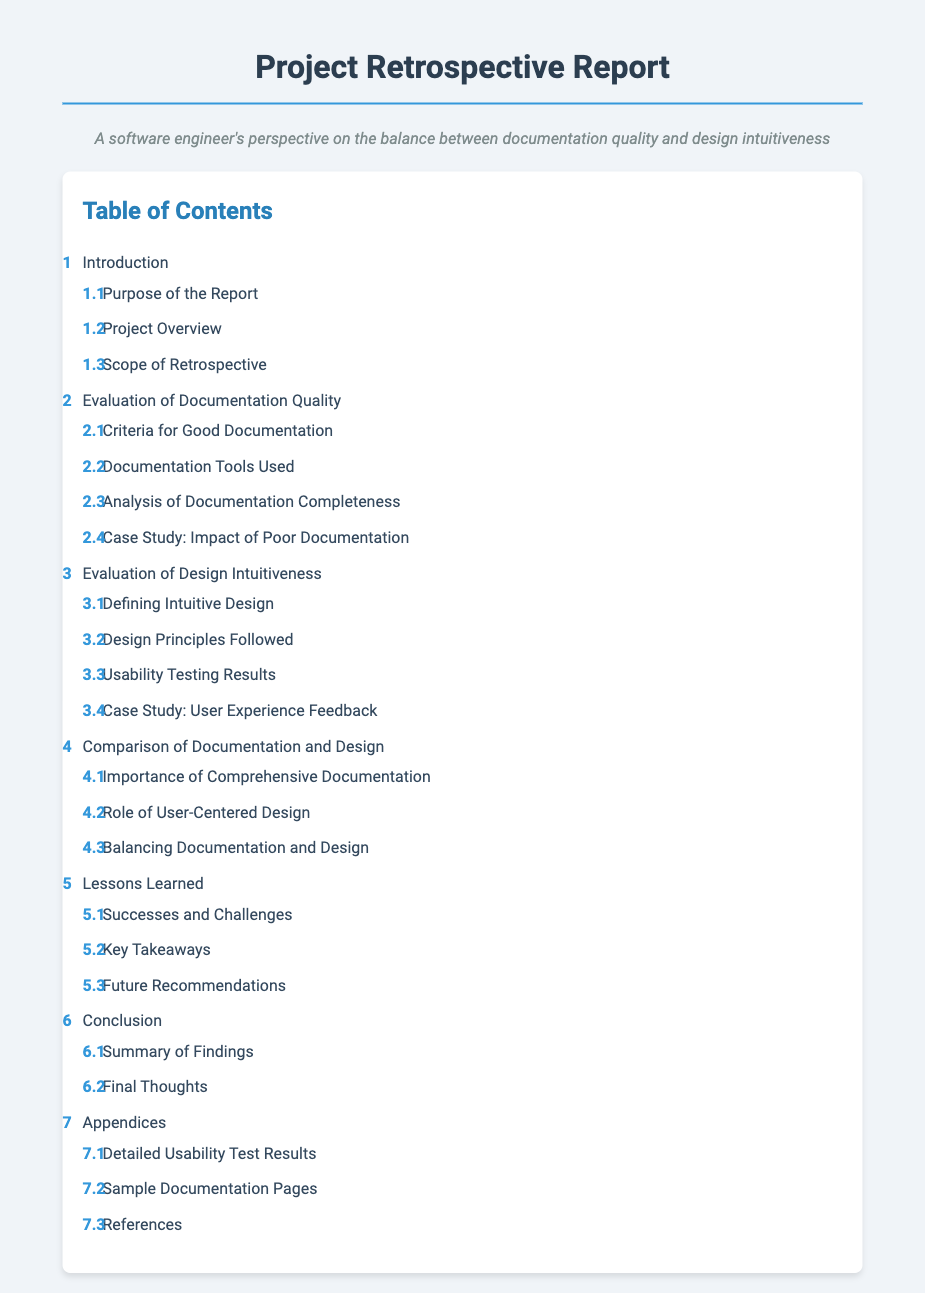What is the title of the document? The title of the document is stated at the top of the rendered content.
Answer: Project Retrospective Report: Documentation Quality and Design Intuitiveness How many main sections are in the Table of Contents? The Table of Contents lists the main sections that can be counted in the rendered document.
Answer: 7 What is the first subsection under "Evaluation of Documentation Quality"? The first subsection pertains to the criteria outlined for assessing the documentation quality.
Answer: Criteria for Good Documentation What case study is mentioned in the documentation section? The case study included is focused on the consequences of lacking good documentation.
Answer: Case Study: Impact of Poor Documentation What does the section on "Evaluation of Design Intuitiveness" primarily address? This section covers various aspects of what constitutes intuitiveness in design.
Answer: Intuitive Design Which section discusses the balance between documentation and design? This section examines how to find a middle ground between effective documentation and intuitive design.
Answer: Balancing Documentation and Design What is the last subsection in the "Lessons Learned" section? The last subsection highlights recommended actions for future projects based on past experiences.
Answer: Future Recommendations What type of feedback is discussed under "Usability Testing Results"? The feedback pertains specifically to user experiences during testing phases.
Answer: Usability Testing Results Which section includes detailed usability test results? This section is dedicated to presenting the results from usability tests performed in the project.
Answer: Detailed Usability Test Results 